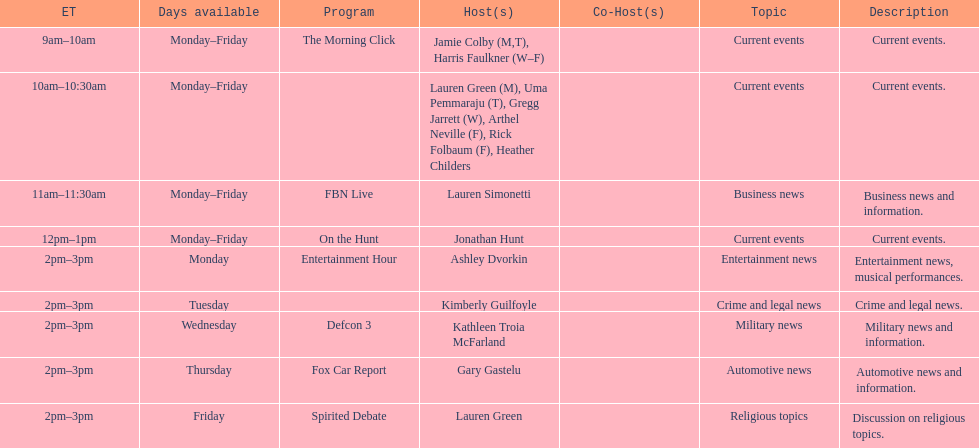Tell me who has her show on fridays at 2. Lauren Green. 